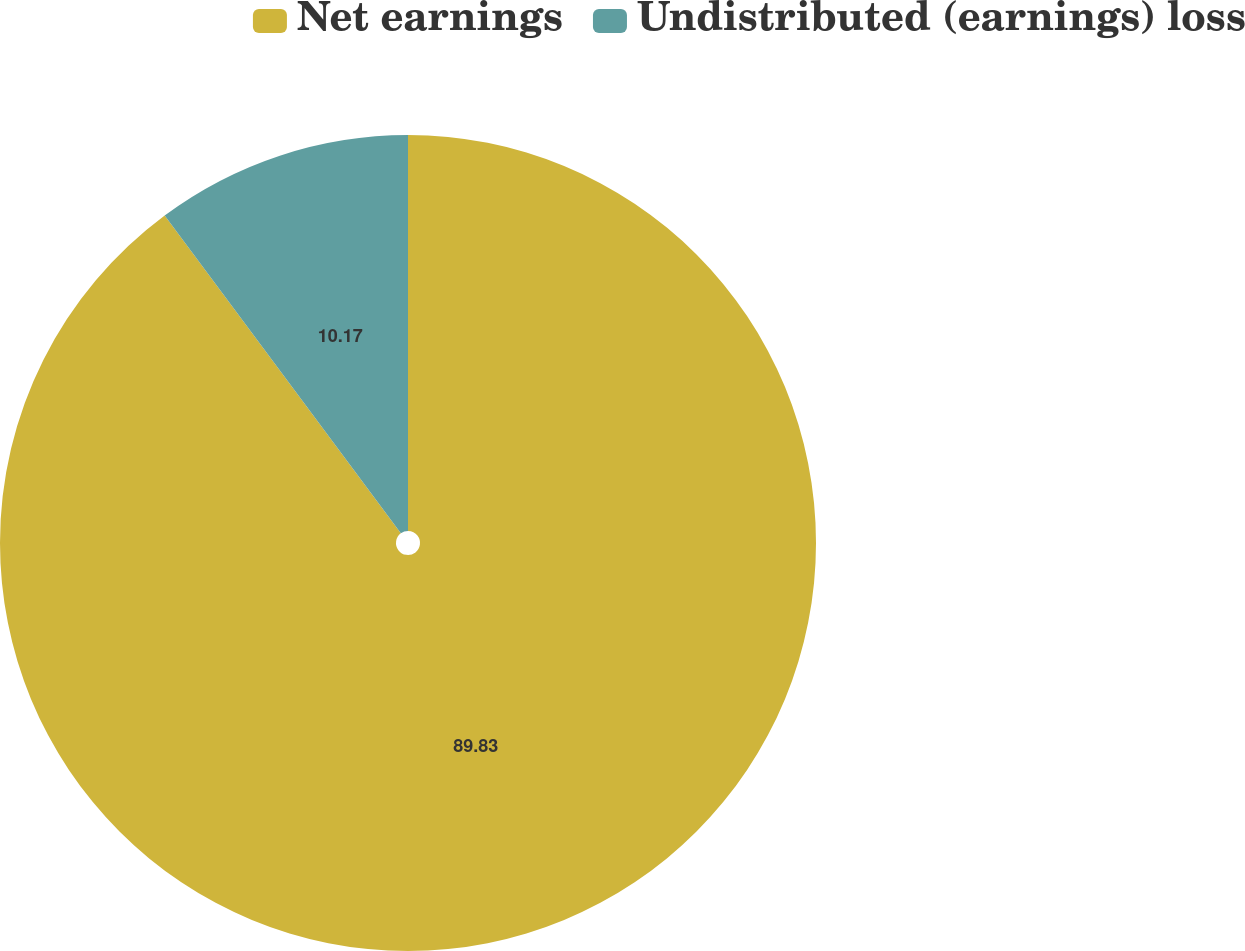Convert chart. <chart><loc_0><loc_0><loc_500><loc_500><pie_chart><fcel>Net earnings<fcel>Undistributed (earnings) loss<nl><fcel>89.83%<fcel>10.17%<nl></chart> 